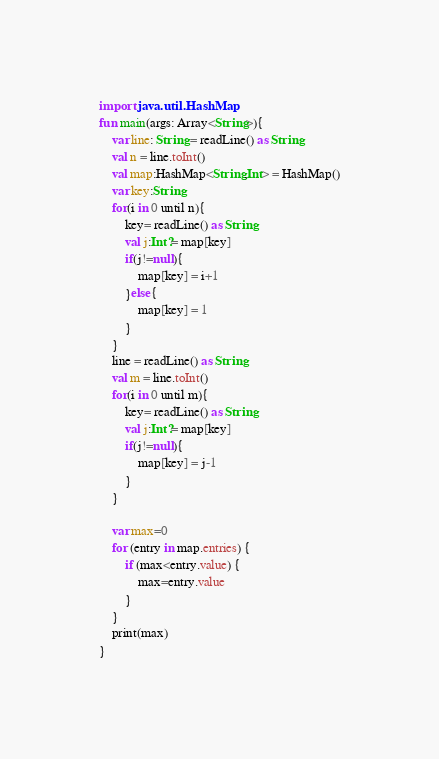Convert code to text. <code><loc_0><loc_0><loc_500><loc_500><_Kotlin_>import java.util.HashMap
fun main(args: Array<String>){
    var line: String = readLine() as String
    val n = line.toInt()
    val map:HashMap<String,Int> = HashMap()
    var key:String
    for(i in 0 until n){
        key= readLine() as String
        val j:Int?= map[key]
        if(j!=null){
            map[key] = i+1
        }else{
            map[key] = 1
        }
    }
    line = readLine() as String
    val m = line.toInt()
    for(i in 0 until m){
        key= readLine() as String
        val j:Int?= map[key]
        if(j!=null){
            map[key] = j-1
        }
    }

    var max=0
    for (entry in map.entries) {
        if (max<entry.value) {
            max=entry.value
        }
    }
    print(max)
}</code> 